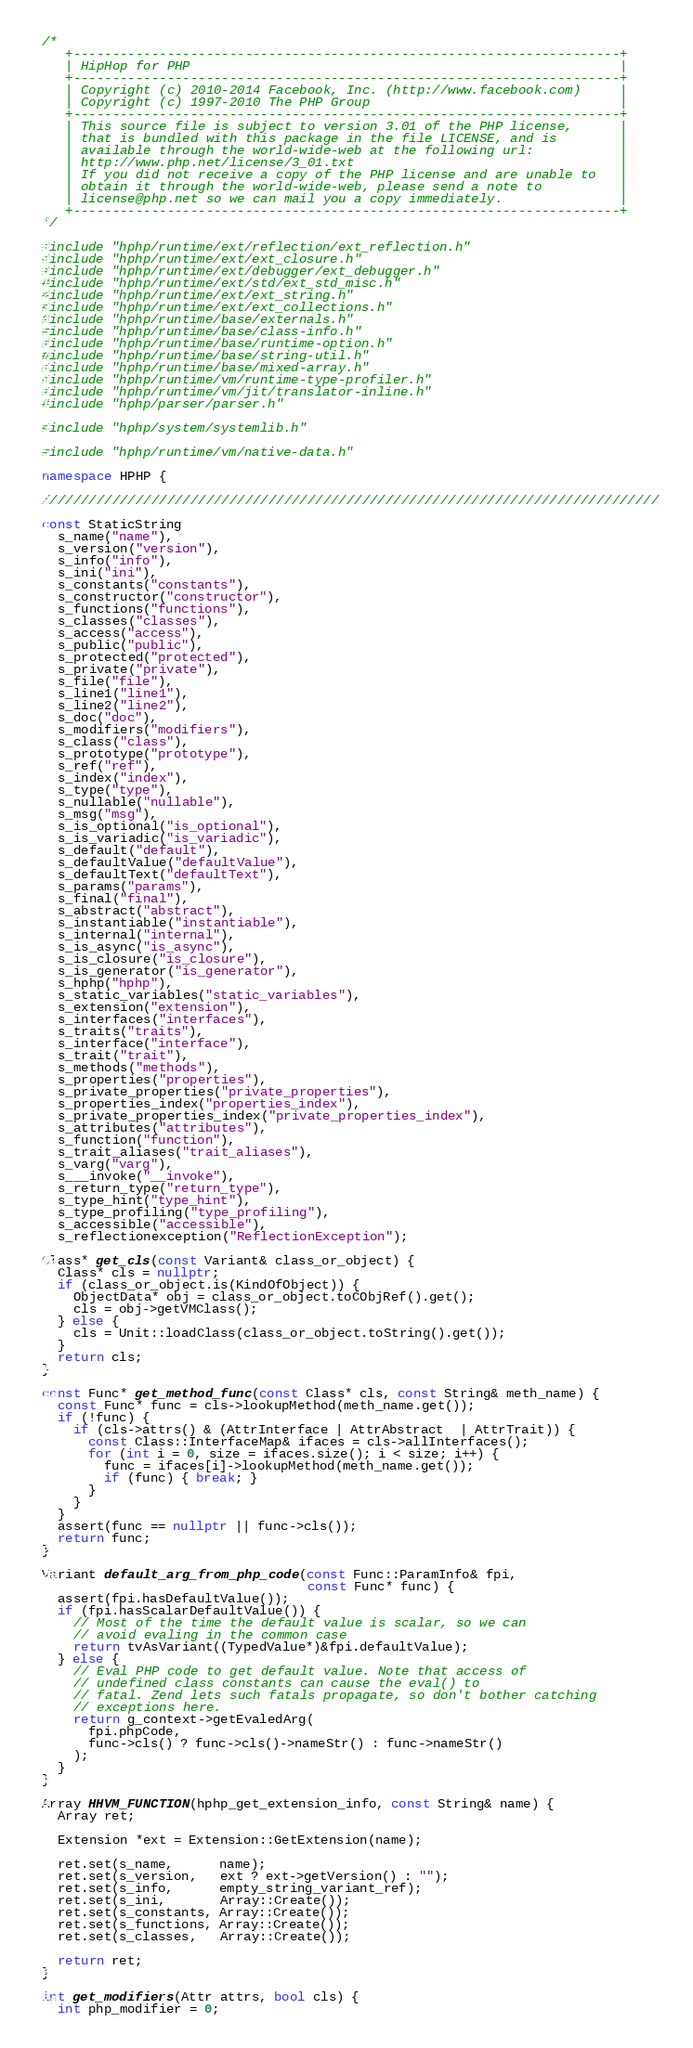<code> <loc_0><loc_0><loc_500><loc_500><_C++_>/*
   +----------------------------------------------------------------------+
   | HipHop for PHP                                                       |
   +----------------------------------------------------------------------+
   | Copyright (c) 2010-2014 Facebook, Inc. (http://www.facebook.com)     |
   | Copyright (c) 1997-2010 The PHP Group                                |
   +----------------------------------------------------------------------+
   | This source file is subject to version 3.01 of the PHP license,      |
   | that is bundled with this package in the file LICENSE, and is        |
   | available through the world-wide-web at the following url:           |
   | http://www.php.net/license/3_01.txt                                  |
   | If you did not receive a copy of the PHP license and are unable to   |
   | obtain it through the world-wide-web, please send a note to          |
   | license@php.net so we can mail you a copy immediately.               |
   +----------------------------------------------------------------------+
*/

#include "hphp/runtime/ext/reflection/ext_reflection.h"
#include "hphp/runtime/ext/ext_closure.h"
#include "hphp/runtime/ext/debugger/ext_debugger.h"
#include "hphp/runtime/ext/std/ext_std_misc.h"
#include "hphp/runtime/ext/ext_string.h"
#include "hphp/runtime/ext/ext_collections.h"
#include "hphp/runtime/base/externals.h"
#include "hphp/runtime/base/class-info.h"
#include "hphp/runtime/base/runtime-option.h"
#include "hphp/runtime/base/string-util.h"
#include "hphp/runtime/base/mixed-array.h"
#include "hphp/runtime/vm/runtime-type-profiler.h"
#include "hphp/runtime/vm/jit/translator-inline.h"
#include "hphp/parser/parser.h"

#include "hphp/system/systemlib.h"

#include "hphp/runtime/vm/native-data.h"

namespace HPHP {

///////////////////////////////////////////////////////////////////////////////

const StaticString
  s_name("name"),
  s_version("version"),
  s_info("info"),
  s_ini("ini"),
  s_constants("constants"),
  s_constructor("constructor"),
  s_functions("functions"),
  s_classes("classes"),
  s_access("access"),
  s_public("public"),
  s_protected("protected"),
  s_private("private"),
  s_file("file"),
  s_line1("line1"),
  s_line2("line2"),
  s_doc("doc"),
  s_modifiers("modifiers"),
  s_class("class"),
  s_prototype("prototype"),
  s_ref("ref"),
  s_index("index"),
  s_type("type"),
  s_nullable("nullable"),
  s_msg("msg"),
  s_is_optional("is_optional"),
  s_is_variadic("is_variadic"),
  s_default("default"),
  s_defaultValue("defaultValue"),
  s_defaultText("defaultText"),
  s_params("params"),
  s_final("final"),
  s_abstract("abstract"),
  s_instantiable("instantiable"),
  s_internal("internal"),
  s_is_async("is_async"),
  s_is_closure("is_closure"),
  s_is_generator("is_generator"),
  s_hphp("hphp"),
  s_static_variables("static_variables"),
  s_extension("extension"),
  s_interfaces("interfaces"),
  s_traits("traits"),
  s_interface("interface"),
  s_trait("trait"),
  s_methods("methods"),
  s_properties("properties"),
  s_private_properties("private_properties"),
  s_properties_index("properties_index"),
  s_private_properties_index("private_properties_index"),
  s_attributes("attributes"),
  s_function("function"),
  s_trait_aliases("trait_aliases"),
  s_varg("varg"),
  s___invoke("__invoke"),
  s_return_type("return_type"),
  s_type_hint("type_hint"),
  s_type_profiling("type_profiling"),
  s_accessible("accessible"),
  s_reflectionexception("ReflectionException");

Class* get_cls(const Variant& class_or_object) {
  Class* cls = nullptr;
  if (class_or_object.is(KindOfObject)) {
    ObjectData* obj = class_or_object.toCObjRef().get();
    cls = obj->getVMClass();
  } else {
    cls = Unit::loadClass(class_or_object.toString().get());
  }
  return cls;
}

const Func* get_method_func(const Class* cls, const String& meth_name) {
  const Func* func = cls->lookupMethod(meth_name.get());
  if (!func) {
    if (cls->attrs() & (AttrInterface | AttrAbstract  | AttrTrait)) {
      const Class::InterfaceMap& ifaces = cls->allInterfaces();
      for (int i = 0, size = ifaces.size(); i < size; i++) {
        func = ifaces[i]->lookupMethod(meth_name.get());
        if (func) { break; }
      }
    }
  }
  assert(func == nullptr || func->cls());
  return func;
}

Variant default_arg_from_php_code(const Func::ParamInfo& fpi,
                                  const Func* func) {
  assert(fpi.hasDefaultValue());
  if (fpi.hasScalarDefaultValue()) {
    // Most of the time the default value is scalar, so we can
    // avoid evaling in the common case
    return tvAsVariant((TypedValue*)&fpi.defaultValue);
  } else {
    // Eval PHP code to get default value. Note that access of
    // undefined class constants can cause the eval() to
    // fatal. Zend lets such fatals propagate, so don't bother catching
    // exceptions here.
    return g_context->getEvaledArg(
      fpi.phpCode,
      func->cls() ? func->cls()->nameStr() : func->nameStr()
    );
  }
}

Array HHVM_FUNCTION(hphp_get_extension_info, const String& name) {
  Array ret;

  Extension *ext = Extension::GetExtension(name);

  ret.set(s_name,      name);
  ret.set(s_version,   ext ? ext->getVersion() : "");
  ret.set(s_info,      empty_string_variant_ref);
  ret.set(s_ini,       Array::Create());
  ret.set(s_constants, Array::Create());
  ret.set(s_functions, Array::Create());
  ret.set(s_classes,   Array::Create());

  return ret;
}

int get_modifiers(Attr attrs, bool cls) {
  int php_modifier = 0;</code> 